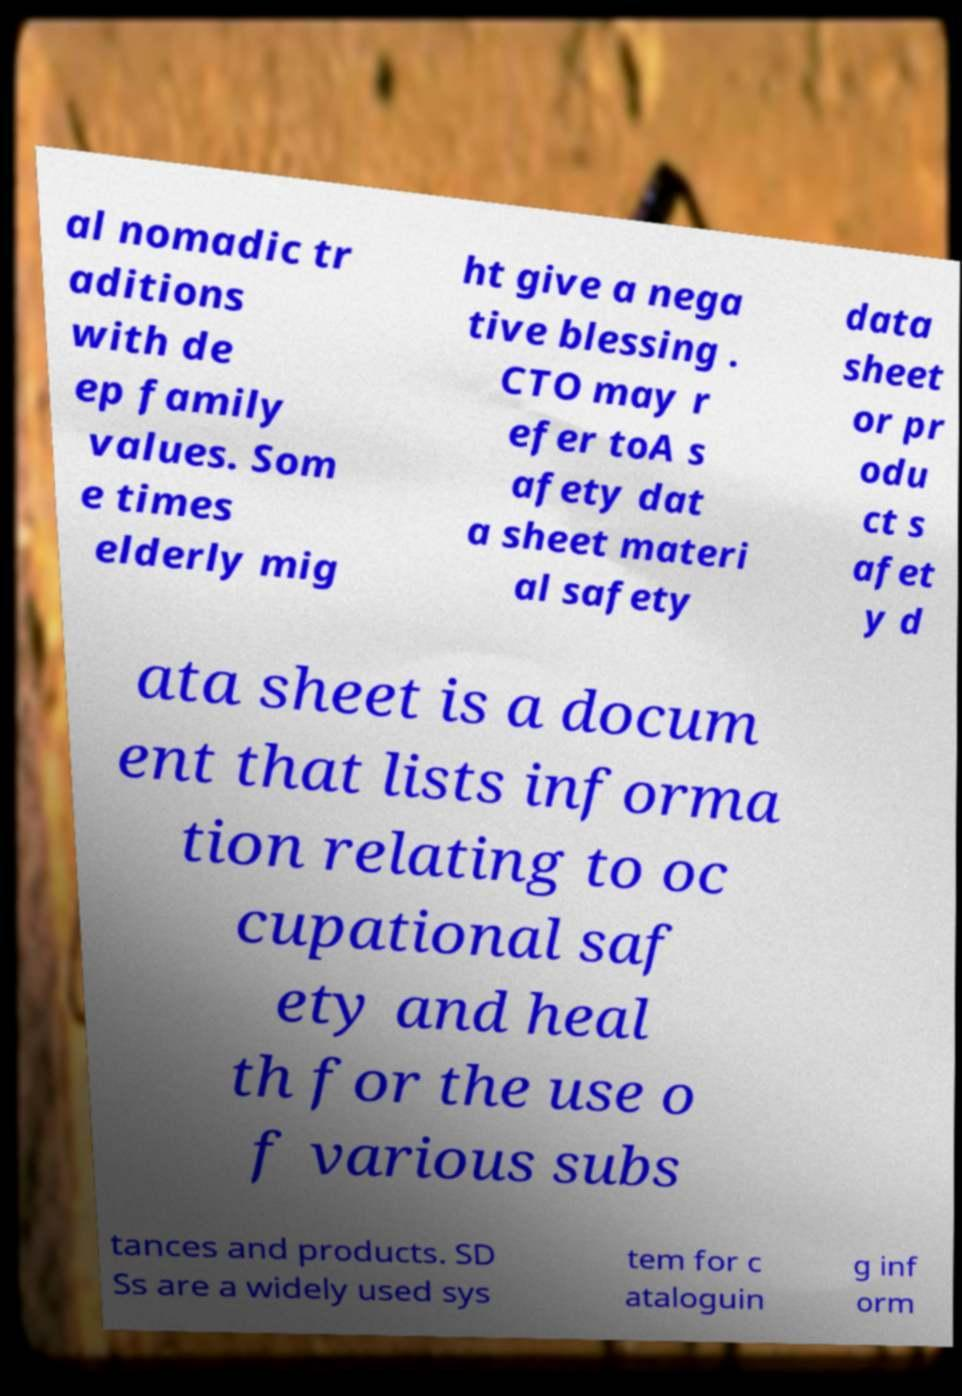Please read and relay the text visible in this image. What does it say? al nomadic tr aditions with de ep family values. Som e times elderly mig ht give a nega tive blessing . CTO may r efer toA s afety dat a sheet materi al safety data sheet or pr odu ct s afet y d ata sheet is a docum ent that lists informa tion relating to oc cupational saf ety and heal th for the use o f various subs tances and products. SD Ss are a widely used sys tem for c ataloguin g inf orm 